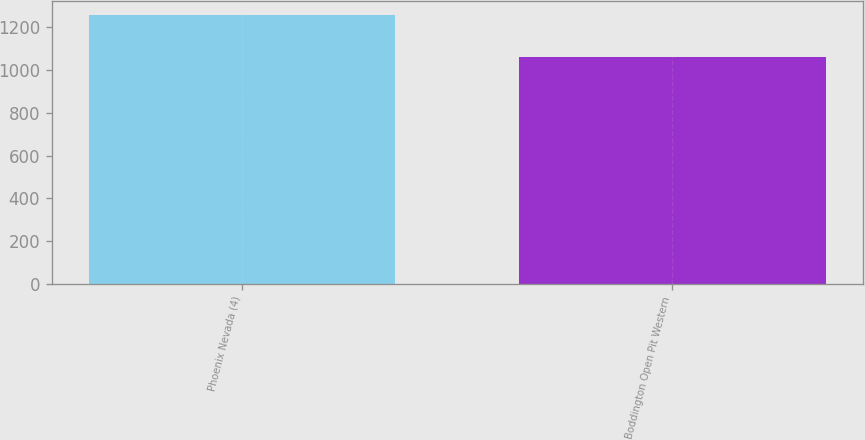<chart> <loc_0><loc_0><loc_500><loc_500><bar_chart><fcel>Phoenix Nevada (4)<fcel>Boddington Open Pit Western<nl><fcel>1260<fcel>1060<nl></chart> 